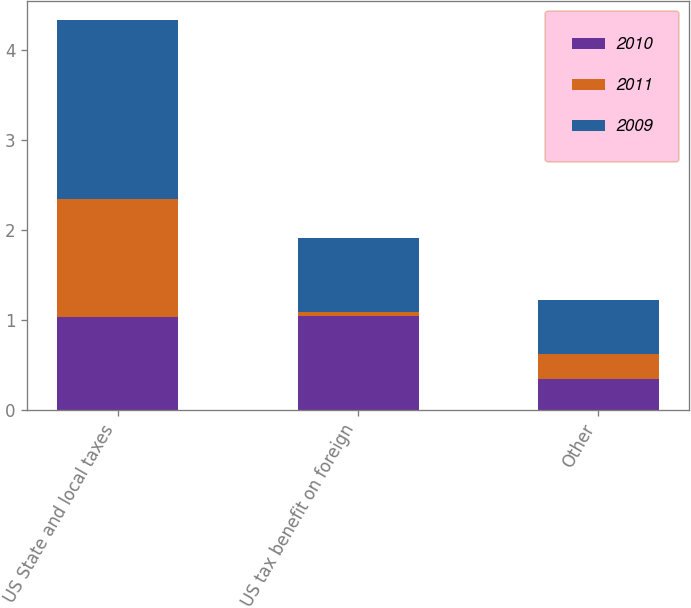Convert chart. <chart><loc_0><loc_0><loc_500><loc_500><stacked_bar_chart><ecel><fcel>US State and local taxes<fcel>US tax benefit on foreign<fcel>Other<nl><fcel>2010<fcel>1.03<fcel>1.04<fcel>0.34<nl><fcel>2011<fcel>1.31<fcel>0.05<fcel>0.28<nl><fcel>2009<fcel>1.99<fcel>0.815<fcel>0.6<nl></chart> 